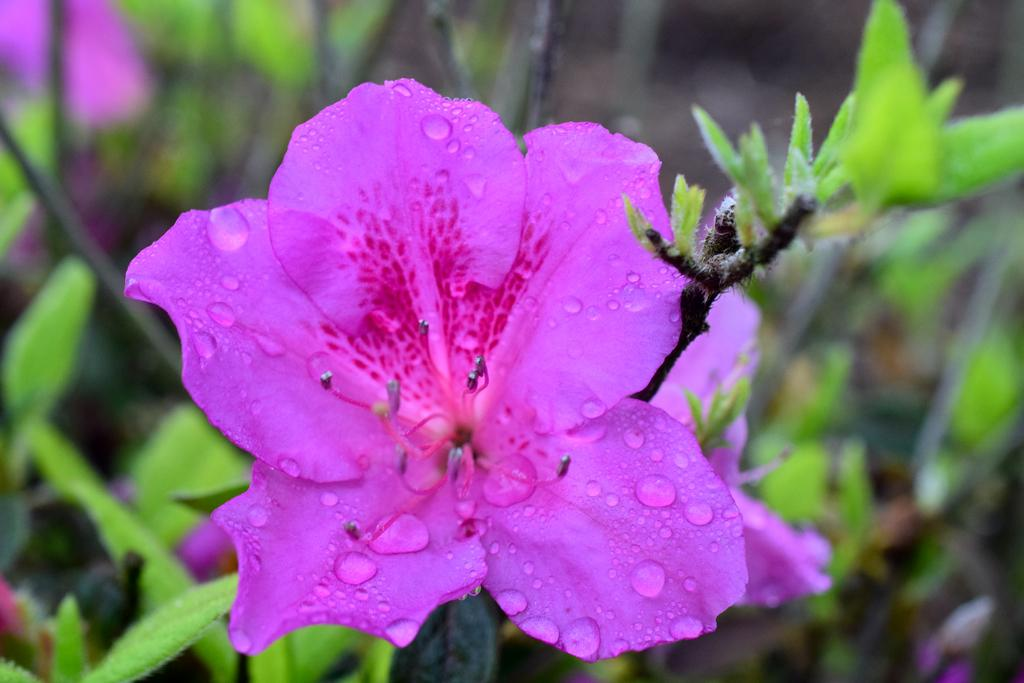What is the main subject of the image? There is a flower with water droplets in the image. What else can be seen in the image besides the main flower? There are stems, leaves, additional flowers, and more stems visible in the image. How many members are on the team in the image? There is no team present in the image; it features a flower with water droplets and related elements. 